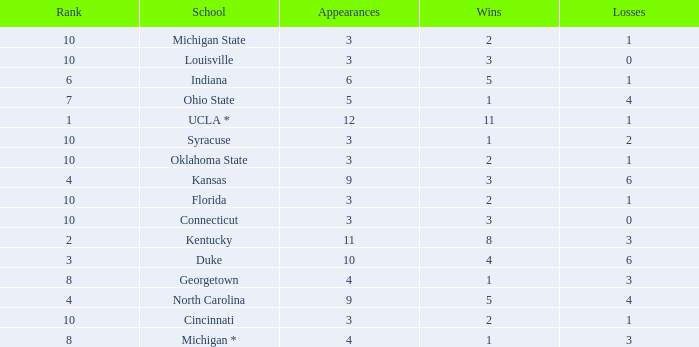Tell me the average Rank for lossess less than 6 and wins less than 11 for michigan state 10.0. 